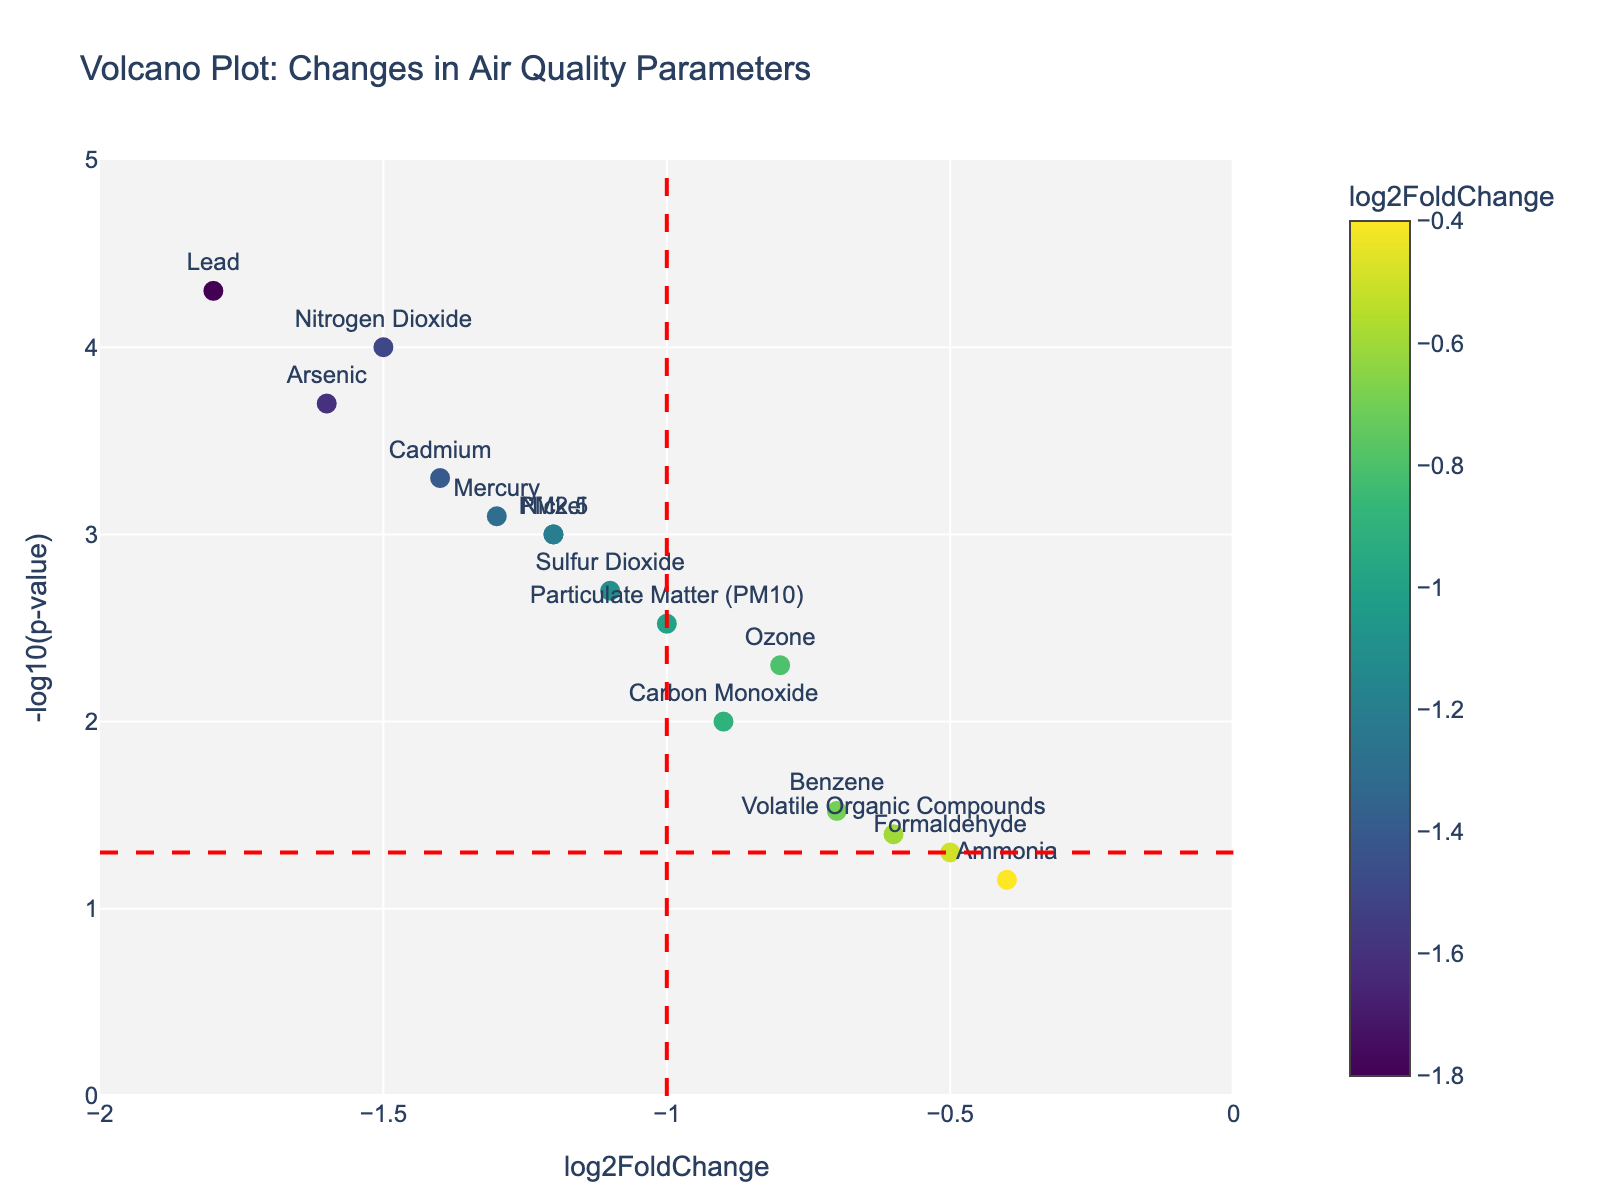how many chemicals are displayed in the plot? The plot displays markers for each chemical. Counting these markers gives us the total number of chemicals.
Answer: 15 What do the colors of the markers represent? The legend or color bar on the plot indicates that the colors of the markers represent the log2FoldChange values for each chemical. Greenish hues indicate lower fold changes, and yellowish hues indicate higher fold changes.
Answer: log2FoldChange values What is the maximum -log10(p-value) in the plot and which chemical does it correspond to? The chemical with the highest y-value in the plot has the maximum -log10(p-value). The highest marker corresponds to Lead.
Answer: Lead How many chemicals have a significant p-value below 0.05? The horizontal red dashed line at y = -log10(0.05) marks the significance threshold. All chemicals above this line have p-values less than 0.05. Count the number of markers above this line.
Answer: 12 Which chemicals have a log2FoldChange less than -1.5? Find the chemicals with x-values to the left of the vertical red dashed line at x = -1.5. These chemicals are Nitrogen Dioxide, Lead, and Arsenic.
Answer: Nitrogen Dioxide, Lead, Arsenic Which chemical shows the least significant change in the plot? The least significant change corresponds to the marker with the lowest -log10(p-value) value. This is Ammonia, as it is closest to the x-axis.
Answer: Ammonia What can be inferred about the chemical "Carbon Monoxide" from its position in the plot? Carbon Monoxide is situated around x = -0.9 and y = 2, showing a log2FoldChange of -0.9 and a -log10(p-value) of 2. Its p-value (10^-2) signifies that the change is statistically significant, indicating reduced levels post-policy implementation.
Answer: reduced levels; significant change 